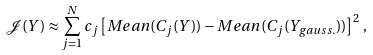<formula> <loc_0><loc_0><loc_500><loc_500>\mathcal { J } ( Y ) \approx \sum _ { j = 1 } ^ { N } c _ { j } \left [ M e a n ( C _ { j } ( Y ) ) - M e a n ( C _ { j } ( Y _ { g a u s s . } ) ) \right ] ^ { 2 } \, ,</formula> 